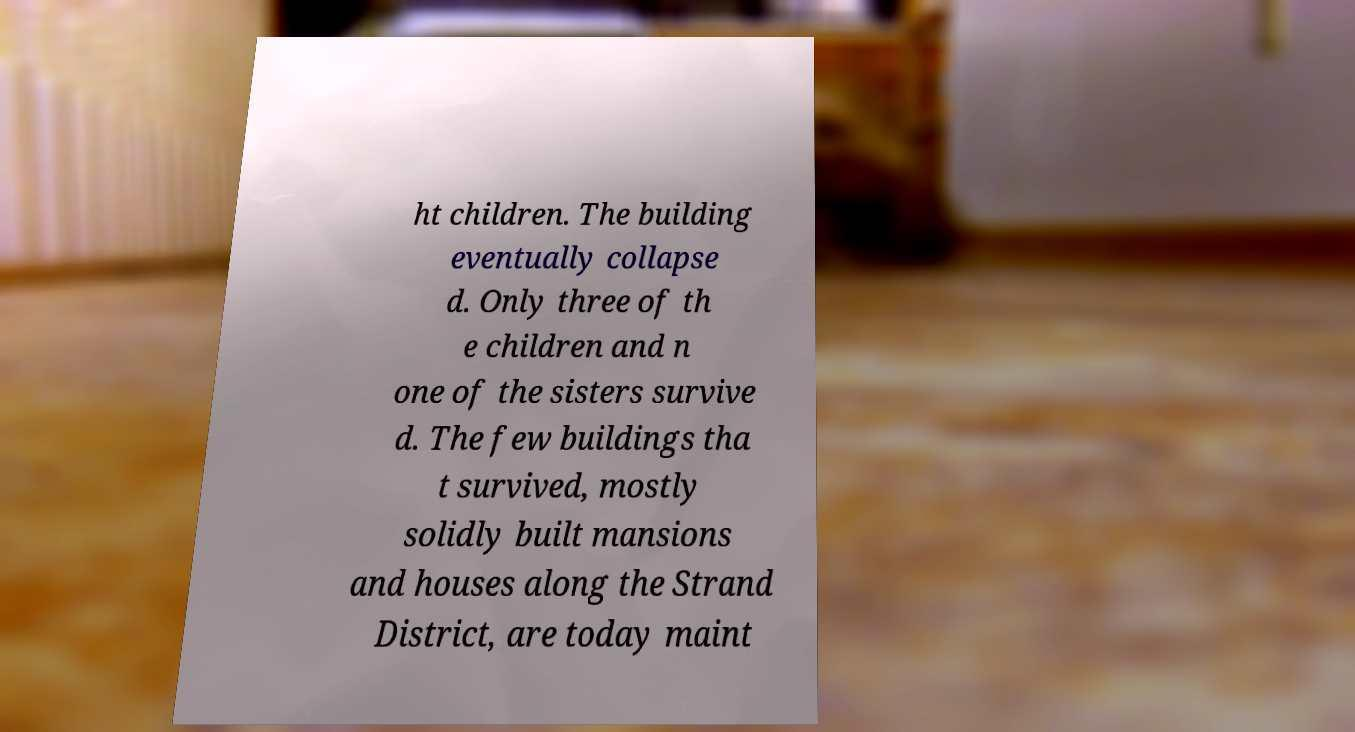Please read and relay the text visible in this image. What does it say? ht children. The building eventually collapse d. Only three of th e children and n one of the sisters survive d. The few buildings tha t survived, mostly solidly built mansions and houses along the Strand District, are today maint 